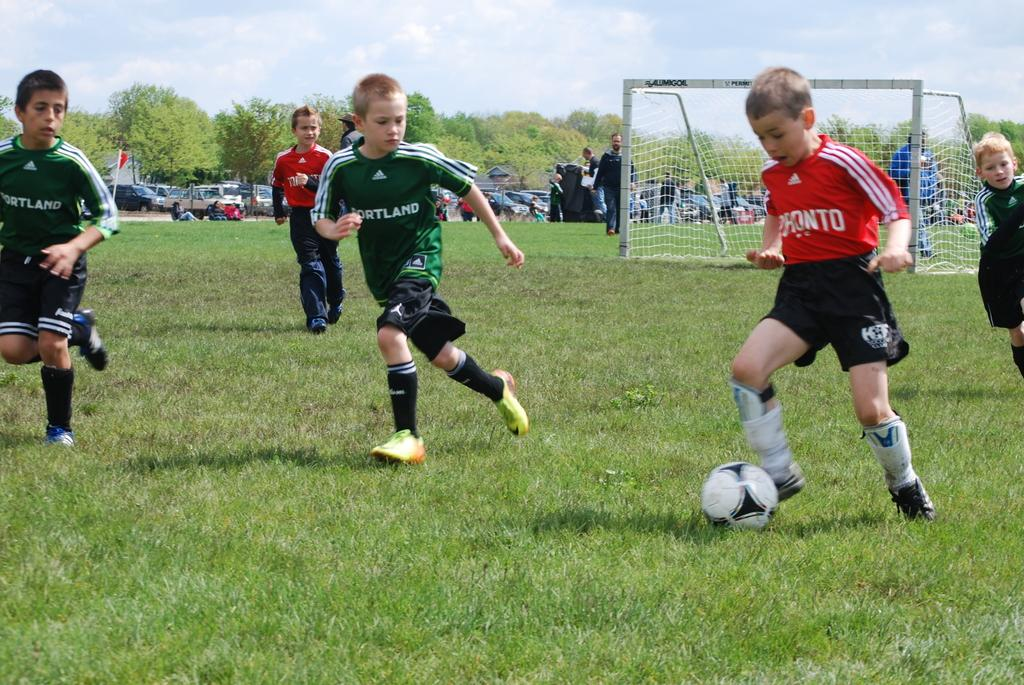<image>
Describe the image concisely. Kids wearing green Portland uniforms play soccer with an opposing team in orange uniforms. 